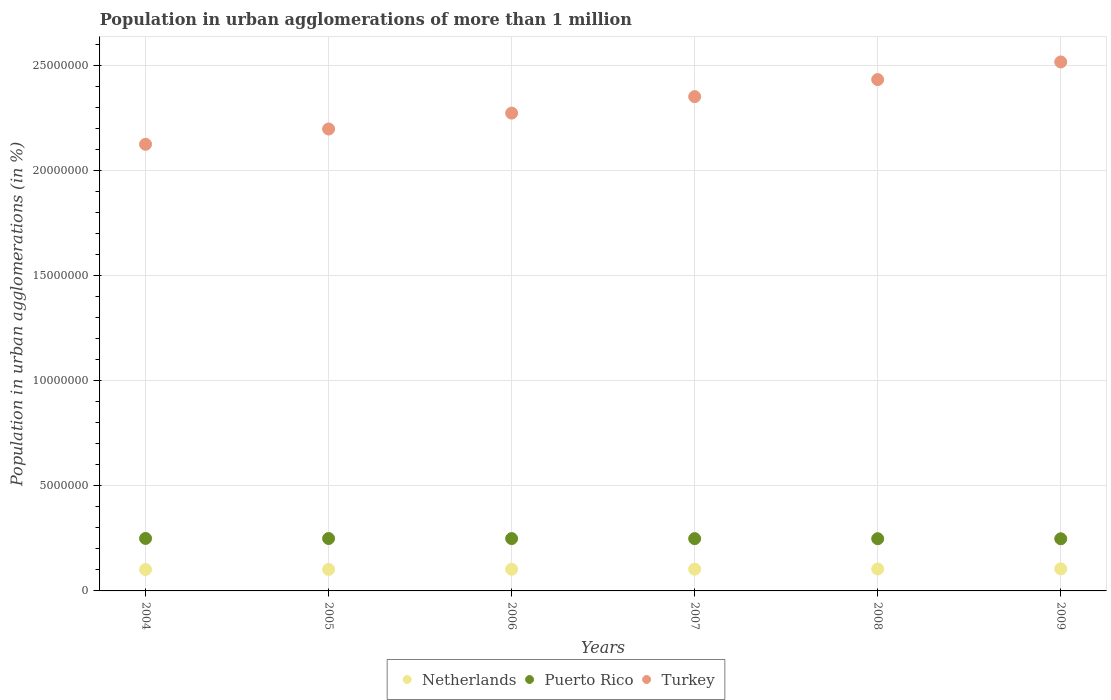Is the number of dotlines equal to the number of legend labels?
Provide a short and direct response. Yes. What is the population in urban agglomerations in Puerto Rico in 2004?
Make the answer very short. 2.50e+06. Across all years, what is the maximum population in urban agglomerations in Netherlands?
Your response must be concise. 1.05e+06. Across all years, what is the minimum population in urban agglomerations in Netherlands?
Make the answer very short. 1.02e+06. In which year was the population in urban agglomerations in Turkey maximum?
Your response must be concise. 2009. In which year was the population in urban agglomerations in Netherlands minimum?
Your answer should be compact. 2004. What is the total population in urban agglomerations in Turkey in the graph?
Provide a succinct answer. 1.39e+08. What is the difference between the population in urban agglomerations in Netherlands in 2004 and that in 2007?
Offer a terse response. -1.79e+04. What is the difference between the population in urban agglomerations in Turkey in 2004 and the population in urban agglomerations in Puerto Rico in 2007?
Your answer should be very brief. 1.88e+07. What is the average population in urban agglomerations in Puerto Rico per year?
Provide a short and direct response. 2.49e+06. In the year 2005, what is the difference between the population in urban agglomerations in Netherlands and population in urban agglomerations in Puerto Rico?
Provide a succinct answer. -1.47e+06. In how many years, is the population in urban agglomerations in Netherlands greater than 25000000 %?
Ensure brevity in your answer.  0. What is the ratio of the population in urban agglomerations in Turkey in 2004 to that in 2007?
Your answer should be very brief. 0.9. What is the difference between the highest and the second highest population in urban agglomerations in Netherlands?
Your answer should be very brief. 6563. What is the difference between the highest and the lowest population in urban agglomerations in Turkey?
Your answer should be very brief. 3.92e+06. Is the sum of the population in urban agglomerations in Turkey in 2004 and 2007 greater than the maximum population in urban agglomerations in Puerto Rico across all years?
Provide a succinct answer. Yes. Does the population in urban agglomerations in Puerto Rico monotonically increase over the years?
Your answer should be compact. No. Is the population in urban agglomerations in Netherlands strictly less than the population in urban agglomerations in Turkey over the years?
Your answer should be very brief. Yes. How many years are there in the graph?
Offer a terse response. 6. Does the graph contain grids?
Give a very brief answer. Yes. Where does the legend appear in the graph?
Make the answer very short. Bottom center. What is the title of the graph?
Your answer should be very brief. Population in urban agglomerations of more than 1 million. What is the label or title of the X-axis?
Your answer should be very brief. Years. What is the label or title of the Y-axis?
Offer a terse response. Population in urban agglomerations (in %). What is the Population in urban agglomerations (in %) in Netherlands in 2004?
Your response must be concise. 1.02e+06. What is the Population in urban agglomerations (in %) of Puerto Rico in 2004?
Give a very brief answer. 2.50e+06. What is the Population in urban agglomerations (in %) in Turkey in 2004?
Ensure brevity in your answer.  2.12e+07. What is the Population in urban agglomerations (in %) in Netherlands in 2005?
Your response must be concise. 1.02e+06. What is the Population in urban agglomerations (in %) of Puerto Rico in 2005?
Offer a terse response. 2.49e+06. What is the Population in urban agglomerations (in %) in Turkey in 2005?
Provide a succinct answer. 2.20e+07. What is the Population in urban agglomerations (in %) of Netherlands in 2006?
Offer a terse response. 1.03e+06. What is the Population in urban agglomerations (in %) in Puerto Rico in 2006?
Your answer should be compact. 2.49e+06. What is the Population in urban agglomerations (in %) of Turkey in 2006?
Keep it short and to the point. 2.27e+07. What is the Population in urban agglomerations (in %) of Netherlands in 2007?
Give a very brief answer. 1.04e+06. What is the Population in urban agglomerations (in %) of Puerto Rico in 2007?
Offer a very short reply. 2.49e+06. What is the Population in urban agglomerations (in %) in Turkey in 2007?
Offer a very short reply. 2.35e+07. What is the Population in urban agglomerations (in %) in Netherlands in 2008?
Your answer should be compact. 1.04e+06. What is the Population in urban agglomerations (in %) in Puerto Rico in 2008?
Keep it short and to the point. 2.48e+06. What is the Population in urban agglomerations (in %) of Turkey in 2008?
Your answer should be compact. 2.43e+07. What is the Population in urban agglomerations (in %) in Netherlands in 2009?
Provide a succinct answer. 1.05e+06. What is the Population in urban agglomerations (in %) of Puerto Rico in 2009?
Make the answer very short. 2.48e+06. What is the Population in urban agglomerations (in %) in Turkey in 2009?
Offer a very short reply. 2.52e+07. Across all years, what is the maximum Population in urban agglomerations (in %) in Netherlands?
Give a very brief answer. 1.05e+06. Across all years, what is the maximum Population in urban agglomerations (in %) of Puerto Rico?
Your answer should be very brief. 2.50e+06. Across all years, what is the maximum Population in urban agglomerations (in %) of Turkey?
Keep it short and to the point. 2.52e+07. Across all years, what is the minimum Population in urban agglomerations (in %) of Netherlands?
Provide a succinct answer. 1.02e+06. Across all years, what is the minimum Population in urban agglomerations (in %) in Puerto Rico?
Keep it short and to the point. 2.48e+06. Across all years, what is the minimum Population in urban agglomerations (in %) in Turkey?
Your answer should be very brief. 2.12e+07. What is the total Population in urban agglomerations (in %) in Netherlands in the graph?
Provide a succinct answer. 6.20e+06. What is the total Population in urban agglomerations (in %) of Puerto Rico in the graph?
Provide a succinct answer. 1.49e+07. What is the total Population in urban agglomerations (in %) in Turkey in the graph?
Provide a short and direct response. 1.39e+08. What is the difference between the Population in urban agglomerations (in %) of Netherlands in 2004 and that in 2005?
Your response must be concise. -5006. What is the difference between the Population in urban agglomerations (in %) in Puerto Rico in 2004 and that in 2005?
Keep it short and to the point. 3008. What is the difference between the Population in urban agglomerations (in %) in Turkey in 2004 and that in 2005?
Give a very brief answer. -7.29e+05. What is the difference between the Population in urban agglomerations (in %) in Netherlands in 2004 and that in 2006?
Provide a succinct answer. -1.15e+04. What is the difference between the Population in urban agglomerations (in %) in Puerto Rico in 2004 and that in 2006?
Your response must be concise. 6016. What is the difference between the Population in urban agglomerations (in %) in Turkey in 2004 and that in 2006?
Give a very brief answer. -1.49e+06. What is the difference between the Population in urban agglomerations (in %) of Netherlands in 2004 and that in 2007?
Offer a terse response. -1.79e+04. What is the difference between the Population in urban agglomerations (in %) of Puerto Rico in 2004 and that in 2007?
Provide a short and direct response. 9020. What is the difference between the Population in urban agglomerations (in %) in Turkey in 2004 and that in 2007?
Provide a short and direct response. -2.27e+06. What is the difference between the Population in urban agglomerations (in %) of Netherlands in 2004 and that in 2008?
Offer a terse response. -2.45e+04. What is the difference between the Population in urban agglomerations (in %) in Puerto Rico in 2004 and that in 2008?
Give a very brief answer. 1.20e+04. What is the difference between the Population in urban agglomerations (in %) of Turkey in 2004 and that in 2008?
Your answer should be compact. -3.08e+06. What is the difference between the Population in urban agglomerations (in %) of Netherlands in 2004 and that in 2009?
Your answer should be compact. -3.10e+04. What is the difference between the Population in urban agglomerations (in %) in Puerto Rico in 2004 and that in 2009?
Your response must be concise. 1.50e+04. What is the difference between the Population in urban agglomerations (in %) of Turkey in 2004 and that in 2009?
Your answer should be compact. -3.92e+06. What is the difference between the Population in urban agglomerations (in %) in Netherlands in 2005 and that in 2006?
Offer a very short reply. -6450. What is the difference between the Population in urban agglomerations (in %) in Puerto Rico in 2005 and that in 2006?
Offer a very short reply. 3008. What is the difference between the Population in urban agglomerations (in %) in Turkey in 2005 and that in 2006?
Your response must be concise. -7.56e+05. What is the difference between the Population in urban agglomerations (in %) of Netherlands in 2005 and that in 2007?
Offer a very short reply. -1.29e+04. What is the difference between the Population in urban agglomerations (in %) in Puerto Rico in 2005 and that in 2007?
Offer a very short reply. 6012. What is the difference between the Population in urban agglomerations (in %) in Turkey in 2005 and that in 2007?
Provide a succinct answer. -1.54e+06. What is the difference between the Population in urban agglomerations (in %) in Netherlands in 2005 and that in 2008?
Your response must be concise. -1.95e+04. What is the difference between the Population in urban agglomerations (in %) in Puerto Rico in 2005 and that in 2008?
Ensure brevity in your answer.  9017. What is the difference between the Population in urban agglomerations (in %) in Turkey in 2005 and that in 2008?
Offer a terse response. -2.35e+06. What is the difference between the Population in urban agglomerations (in %) of Netherlands in 2005 and that in 2009?
Give a very brief answer. -2.60e+04. What is the difference between the Population in urban agglomerations (in %) of Puerto Rico in 2005 and that in 2009?
Offer a terse response. 1.20e+04. What is the difference between the Population in urban agglomerations (in %) of Turkey in 2005 and that in 2009?
Your response must be concise. -3.19e+06. What is the difference between the Population in urban agglomerations (in %) in Netherlands in 2006 and that in 2007?
Your answer should be compact. -6490. What is the difference between the Population in urban agglomerations (in %) in Puerto Rico in 2006 and that in 2007?
Your answer should be very brief. 3004. What is the difference between the Population in urban agglomerations (in %) of Turkey in 2006 and that in 2007?
Make the answer very short. -7.83e+05. What is the difference between the Population in urban agglomerations (in %) in Netherlands in 2006 and that in 2008?
Ensure brevity in your answer.  -1.30e+04. What is the difference between the Population in urban agglomerations (in %) of Puerto Rico in 2006 and that in 2008?
Keep it short and to the point. 6009. What is the difference between the Population in urban agglomerations (in %) in Turkey in 2006 and that in 2008?
Provide a succinct answer. -1.59e+06. What is the difference between the Population in urban agglomerations (in %) of Netherlands in 2006 and that in 2009?
Your response must be concise. -1.96e+04. What is the difference between the Population in urban agglomerations (in %) in Puerto Rico in 2006 and that in 2009?
Offer a terse response. 9002. What is the difference between the Population in urban agglomerations (in %) in Turkey in 2006 and that in 2009?
Give a very brief answer. -2.43e+06. What is the difference between the Population in urban agglomerations (in %) of Netherlands in 2007 and that in 2008?
Offer a terse response. -6540. What is the difference between the Population in urban agglomerations (in %) of Puerto Rico in 2007 and that in 2008?
Make the answer very short. 3005. What is the difference between the Population in urban agglomerations (in %) of Turkey in 2007 and that in 2008?
Provide a short and direct response. -8.12e+05. What is the difference between the Population in urban agglomerations (in %) of Netherlands in 2007 and that in 2009?
Your response must be concise. -1.31e+04. What is the difference between the Population in urban agglomerations (in %) of Puerto Rico in 2007 and that in 2009?
Ensure brevity in your answer.  5998. What is the difference between the Population in urban agglomerations (in %) in Turkey in 2007 and that in 2009?
Your response must be concise. -1.65e+06. What is the difference between the Population in urban agglomerations (in %) of Netherlands in 2008 and that in 2009?
Your answer should be very brief. -6563. What is the difference between the Population in urban agglomerations (in %) of Puerto Rico in 2008 and that in 2009?
Provide a short and direct response. 2993. What is the difference between the Population in urban agglomerations (in %) in Turkey in 2008 and that in 2009?
Your response must be concise. -8.39e+05. What is the difference between the Population in urban agglomerations (in %) of Netherlands in 2004 and the Population in urban agglomerations (in %) of Puerto Rico in 2005?
Your answer should be compact. -1.47e+06. What is the difference between the Population in urban agglomerations (in %) of Netherlands in 2004 and the Population in urban agglomerations (in %) of Turkey in 2005?
Your answer should be compact. -2.10e+07. What is the difference between the Population in urban agglomerations (in %) of Puerto Rico in 2004 and the Population in urban agglomerations (in %) of Turkey in 2005?
Provide a short and direct response. -1.95e+07. What is the difference between the Population in urban agglomerations (in %) in Netherlands in 2004 and the Population in urban agglomerations (in %) in Puerto Rico in 2006?
Ensure brevity in your answer.  -1.47e+06. What is the difference between the Population in urban agglomerations (in %) in Netherlands in 2004 and the Population in urban agglomerations (in %) in Turkey in 2006?
Ensure brevity in your answer.  -2.17e+07. What is the difference between the Population in urban agglomerations (in %) of Puerto Rico in 2004 and the Population in urban agglomerations (in %) of Turkey in 2006?
Your answer should be compact. -2.02e+07. What is the difference between the Population in urban agglomerations (in %) in Netherlands in 2004 and the Population in urban agglomerations (in %) in Puerto Rico in 2007?
Offer a very short reply. -1.47e+06. What is the difference between the Population in urban agglomerations (in %) in Netherlands in 2004 and the Population in urban agglomerations (in %) in Turkey in 2007?
Provide a succinct answer. -2.25e+07. What is the difference between the Population in urban agglomerations (in %) in Puerto Rico in 2004 and the Population in urban agglomerations (in %) in Turkey in 2007?
Your answer should be compact. -2.10e+07. What is the difference between the Population in urban agglomerations (in %) of Netherlands in 2004 and the Population in urban agglomerations (in %) of Puerto Rico in 2008?
Provide a succinct answer. -1.47e+06. What is the difference between the Population in urban agglomerations (in %) of Netherlands in 2004 and the Population in urban agglomerations (in %) of Turkey in 2008?
Your answer should be compact. -2.33e+07. What is the difference between the Population in urban agglomerations (in %) in Puerto Rico in 2004 and the Population in urban agglomerations (in %) in Turkey in 2008?
Keep it short and to the point. -2.18e+07. What is the difference between the Population in urban agglomerations (in %) of Netherlands in 2004 and the Population in urban agglomerations (in %) of Puerto Rico in 2009?
Your response must be concise. -1.46e+06. What is the difference between the Population in urban agglomerations (in %) of Netherlands in 2004 and the Population in urban agglomerations (in %) of Turkey in 2009?
Give a very brief answer. -2.41e+07. What is the difference between the Population in urban agglomerations (in %) of Puerto Rico in 2004 and the Population in urban agglomerations (in %) of Turkey in 2009?
Provide a succinct answer. -2.27e+07. What is the difference between the Population in urban agglomerations (in %) of Netherlands in 2005 and the Population in urban agglomerations (in %) of Puerto Rico in 2006?
Offer a very short reply. -1.47e+06. What is the difference between the Population in urban agglomerations (in %) in Netherlands in 2005 and the Population in urban agglomerations (in %) in Turkey in 2006?
Offer a terse response. -2.17e+07. What is the difference between the Population in urban agglomerations (in %) in Puerto Rico in 2005 and the Population in urban agglomerations (in %) in Turkey in 2006?
Make the answer very short. -2.02e+07. What is the difference between the Population in urban agglomerations (in %) in Netherlands in 2005 and the Population in urban agglomerations (in %) in Puerto Rico in 2007?
Offer a very short reply. -1.46e+06. What is the difference between the Population in urban agglomerations (in %) of Netherlands in 2005 and the Population in urban agglomerations (in %) of Turkey in 2007?
Offer a very short reply. -2.25e+07. What is the difference between the Population in urban agglomerations (in %) in Puerto Rico in 2005 and the Population in urban agglomerations (in %) in Turkey in 2007?
Provide a short and direct response. -2.10e+07. What is the difference between the Population in urban agglomerations (in %) of Netherlands in 2005 and the Population in urban agglomerations (in %) of Puerto Rico in 2008?
Your answer should be very brief. -1.46e+06. What is the difference between the Population in urban agglomerations (in %) in Netherlands in 2005 and the Population in urban agglomerations (in %) in Turkey in 2008?
Provide a succinct answer. -2.33e+07. What is the difference between the Population in urban agglomerations (in %) of Puerto Rico in 2005 and the Population in urban agglomerations (in %) of Turkey in 2008?
Provide a succinct answer. -2.18e+07. What is the difference between the Population in urban agglomerations (in %) in Netherlands in 2005 and the Population in urban agglomerations (in %) in Puerto Rico in 2009?
Provide a succinct answer. -1.46e+06. What is the difference between the Population in urban agglomerations (in %) of Netherlands in 2005 and the Population in urban agglomerations (in %) of Turkey in 2009?
Offer a very short reply. -2.41e+07. What is the difference between the Population in urban agglomerations (in %) in Puerto Rico in 2005 and the Population in urban agglomerations (in %) in Turkey in 2009?
Your answer should be very brief. -2.27e+07. What is the difference between the Population in urban agglomerations (in %) of Netherlands in 2006 and the Population in urban agglomerations (in %) of Puerto Rico in 2007?
Offer a very short reply. -1.46e+06. What is the difference between the Population in urban agglomerations (in %) in Netherlands in 2006 and the Population in urban agglomerations (in %) in Turkey in 2007?
Your answer should be compact. -2.25e+07. What is the difference between the Population in urban agglomerations (in %) of Puerto Rico in 2006 and the Population in urban agglomerations (in %) of Turkey in 2007?
Provide a succinct answer. -2.10e+07. What is the difference between the Population in urban agglomerations (in %) in Netherlands in 2006 and the Population in urban agglomerations (in %) in Puerto Rico in 2008?
Provide a short and direct response. -1.45e+06. What is the difference between the Population in urban agglomerations (in %) of Netherlands in 2006 and the Population in urban agglomerations (in %) of Turkey in 2008?
Give a very brief answer. -2.33e+07. What is the difference between the Population in urban agglomerations (in %) of Puerto Rico in 2006 and the Population in urban agglomerations (in %) of Turkey in 2008?
Offer a very short reply. -2.18e+07. What is the difference between the Population in urban agglomerations (in %) of Netherlands in 2006 and the Population in urban agglomerations (in %) of Puerto Rico in 2009?
Give a very brief answer. -1.45e+06. What is the difference between the Population in urban agglomerations (in %) of Netherlands in 2006 and the Population in urban agglomerations (in %) of Turkey in 2009?
Your response must be concise. -2.41e+07. What is the difference between the Population in urban agglomerations (in %) of Puerto Rico in 2006 and the Population in urban agglomerations (in %) of Turkey in 2009?
Ensure brevity in your answer.  -2.27e+07. What is the difference between the Population in urban agglomerations (in %) in Netherlands in 2007 and the Population in urban agglomerations (in %) in Puerto Rico in 2008?
Give a very brief answer. -1.45e+06. What is the difference between the Population in urban agglomerations (in %) of Netherlands in 2007 and the Population in urban agglomerations (in %) of Turkey in 2008?
Give a very brief answer. -2.33e+07. What is the difference between the Population in urban agglomerations (in %) in Puerto Rico in 2007 and the Population in urban agglomerations (in %) in Turkey in 2008?
Give a very brief answer. -2.18e+07. What is the difference between the Population in urban agglomerations (in %) of Netherlands in 2007 and the Population in urban agglomerations (in %) of Puerto Rico in 2009?
Ensure brevity in your answer.  -1.44e+06. What is the difference between the Population in urban agglomerations (in %) in Netherlands in 2007 and the Population in urban agglomerations (in %) in Turkey in 2009?
Provide a succinct answer. -2.41e+07. What is the difference between the Population in urban agglomerations (in %) of Puerto Rico in 2007 and the Population in urban agglomerations (in %) of Turkey in 2009?
Make the answer very short. -2.27e+07. What is the difference between the Population in urban agglomerations (in %) of Netherlands in 2008 and the Population in urban agglomerations (in %) of Puerto Rico in 2009?
Ensure brevity in your answer.  -1.44e+06. What is the difference between the Population in urban agglomerations (in %) in Netherlands in 2008 and the Population in urban agglomerations (in %) in Turkey in 2009?
Provide a short and direct response. -2.41e+07. What is the difference between the Population in urban agglomerations (in %) in Puerto Rico in 2008 and the Population in urban agglomerations (in %) in Turkey in 2009?
Offer a terse response. -2.27e+07. What is the average Population in urban agglomerations (in %) in Netherlands per year?
Offer a terse response. 1.03e+06. What is the average Population in urban agglomerations (in %) of Puerto Rico per year?
Ensure brevity in your answer.  2.49e+06. What is the average Population in urban agglomerations (in %) of Turkey per year?
Give a very brief answer. 2.32e+07. In the year 2004, what is the difference between the Population in urban agglomerations (in %) of Netherlands and Population in urban agglomerations (in %) of Puerto Rico?
Give a very brief answer. -1.48e+06. In the year 2004, what is the difference between the Population in urban agglomerations (in %) of Netherlands and Population in urban agglomerations (in %) of Turkey?
Give a very brief answer. -2.02e+07. In the year 2004, what is the difference between the Population in urban agglomerations (in %) in Puerto Rico and Population in urban agglomerations (in %) in Turkey?
Your response must be concise. -1.88e+07. In the year 2005, what is the difference between the Population in urban agglomerations (in %) of Netherlands and Population in urban agglomerations (in %) of Puerto Rico?
Offer a very short reply. -1.47e+06. In the year 2005, what is the difference between the Population in urban agglomerations (in %) of Netherlands and Population in urban agglomerations (in %) of Turkey?
Make the answer very short. -2.10e+07. In the year 2005, what is the difference between the Population in urban agglomerations (in %) of Puerto Rico and Population in urban agglomerations (in %) of Turkey?
Keep it short and to the point. -1.95e+07. In the year 2006, what is the difference between the Population in urban agglomerations (in %) in Netherlands and Population in urban agglomerations (in %) in Puerto Rico?
Make the answer very short. -1.46e+06. In the year 2006, what is the difference between the Population in urban agglomerations (in %) in Netherlands and Population in urban agglomerations (in %) in Turkey?
Offer a terse response. -2.17e+07. In the year 2006, what is the difference between the Population in urban agglomerations (in %) in Puerto Rico and Population in urban agglomerations (in %) in Turkey?
Give a very brief answer. -2.02e+07. In the year 2007, what is the difference between the Population in urban agglomerations (in %) in Netherlands and Population in urban agglomerations (in %) in Puerto Rico?
Give a very brief answer. -1.45e+06. In the year 2007, what is the difference between the Population in urban agglomerations (in %) of Netherlands and Population in urban agglomerations (in %) of Turkey?
Make the answer very short. -2.25e+07. In the year 2007, what is the difference between the Population in urban agglomerations (in %) in Puerto Rico and Population in urban agglomerations (in %) in Turkey?
Give a very brief answer. -2.10e+07. In the year 2008, what is the difference between the Population in urban agglomerations (in %) of Netherlands and Population in urban agglomerations (in %) of Puerto Rico?
Your answer should be compact. -1.44e+06. In the year 2008, what is the difference between the Population in urban agglomerations (in %) in Netherlands and Population in urban agglomerations (in %) in Turkey?
Your answer should be compact. -2.33e+07. In the year 2008, what is the difference between the Population in urban agglomerations (in %) of Puerto Rico and Population in urban agglomerations (in %) of Turkey?
Your response must be concise. -2.18e+07. In the year 2009, what is the difference between the Population in urban agglomerations (in %) of Netherlands and Population in urban agglomerations (in %) of Puerto Rico?
Your answer should be compact. -1.43e+06. In the year 2009, what is the difference between the Population in urban agglomerations (in %) in Netherlands and Population in urban agglomerations (in %) in Turkey?
Offer a terse response. -2.41e+07. In the year 2009, what is the difference between the Population in urban agglomerations (in %) of Puerto Rico and Population in urban agglomerations (in %) of Turkey?
Offer a terse response. -2.27e+07. What is the ratio of the Population in urban agglomerations (in %) in Netherlands in 2004 to that in 2005?
Your answer should be compact. 1. What is the ratio of the Population in urban agglomerations (in %) of Turkey in 2004 to that in 2005?
Keep it short and to the point. 0.97. What is the ratio of the Population in urban agglomerations (in %) of Netherlands in 2004 to that in 2006?
Offer a terse response. 0.99. What is the ratio of the Population in urban agglomerations (in %) of Puerto Rico in 2004 to that in 2006?
Your answer should be very brief. 1. What is the ratio of the Population in urban agglomerations (in %) in Turkey in 2004 to that in 2006?
Keep it short and to the point. 0.93. What is the ratio of the Population in urban agglomerations (in %) of Netherlands in 2004 to that in 2007?
Provide a short and direct response. 0.98. What is the ratio of the Population in urban agglomerations (in %) of Puerto Rico in 2004 to that in 2007?
Offer a terse response. 1. What is the ratio of the Population in urban agglomerations (in %) in Turkey in 2004 to that in 2007?
Offer a terse response. 0.9. What is the ratio of the Population in urban agglomerations (in %) of Netherlands in 2004 to that in 2008?
Make the answer very short. 0.98. What is the ratio of the Population in urban agglomerations (in %) of Turkey in 2004 to that in 2008?
Ensure brevity in your answer.  0.87. What is the ratio of the Population in urban agglomerations (in %) in Netherlands in 2004 to that in 2009?
Keep it short and to the point. 0.97. What is the ratio of the Population in urban agglomerations (in %) of Turkey in 2004 to that in 2009?
Give a very brief answer. 0.84. What is the ratio of the Population in urban agglomerations (in %) of Puerto Rico in 2005 to that in 2006?
Your answer should be compact. 1. What is the ratio of the Population in urban agglomerations (in %) in Turkey in 2005 to that in 2006?
Keep it short and to the point. 0.97. What is the ratio of the Population in urban agglomerations (in %) of Netherlands in 2005 to that in 2007?
Your answer should be very brief. 0.99. What is the ratio of the Population in urban agglomerations (in %) of Turkey in 2005 to that in 2007?
Provide a succinct answer. 0.93. What is the ratio of the Population in urban agglomerations (in %) of Netherlands in 2005 to that in 2008?
Provide a succinct answer. 0.98. What is the ratio of the Population in urban agglomerations (in %) in Puerto Rico in 2005 to that in 2008?
Ensure brevity in your answer.  1. What is the ratio of the Population in urban agglomerations (in %) of Turkey in 2005 to that in 2008?
Ensure brevity in your answer.  0.9. What is the ratio of the Population in urban agglomerations (in %) of Netherlands in 2005 to that in 2009?
Give a very brief answer. 0.98. What is the ratio of the Population in urban agglomerations (in %) of Puerto Rico in 2005 to that in 2009?
Give a very brief answer. 1. What is the ratio of the Population in urban agglomerations (in %) of Turkey in 2005 to that in 2009?
Ensure brevity in your answer.  0.87. What is the ratio of the Population in urban agglomerations (in %) in Netherlands in 2006 to that in 2007?
Your answer should be compact. 0.99. What is the ratio of the Population in urban agglomerations (in %) in Puerto Rico in 2006 to that in 2007?
Make the answer very short. 1. What is the ratio of the Population in urban agglomerations (in %) of Turkey in 2006 to that in 2007?
Offer a terse response. 0.97. What is the ratio of the Population in urban agglomerations (in %) of Netherlands in 2006 to that in 2008?
Your answer should be very brief. 0.99. What is the ratio of the Population in urban agglomerations (in %) in Turkey in 2006 to that in 2008?
Provide a succinct answer. 0.93. What is the ratio of the Population in urban agglomerations (in %) of Netherlands in 2006 to that in 2009?
Keep it short and to the point. 0.98. What is the ratio of the Population in urban agglomerations (in %) of Puerto Rico in 2006 to that in 2009?
Your answer should be very brief. 1. What is the ratio of the Population in urban agglomerations (in %) of Turkey in 2006 to that in 2009?
Give a very brief answer. 0.9. What is the ratio of the Population in urban agglomerations (in %) in Netherlands in 2007 to that in 2008?
Offer a terse response. 0.99. What is the ratio of the Population in urban agglomerations (in %) of Turkey in 2007 to that in 2008?
Offer a very short reply. 0.97. What is the ratio of the Population in urban agglomerations (in %) of Netherlands in 2007 to that in 2009?
Your answer should be very brief. 0.99. What is the ratio of the Population in urban agglomerations (in %) in Turkey in 2007 to that in 2009?
Your answer should be compact. 0.93. What is the ratio of the Population in urban agglomerations (in %) in Turkey in 2008 to that in 2009?
Your response must be concise. 0.97. What is the difference between the highest and the second highest Population in urban agglomerations (in %) in Netherlands?
Ensure brevity in your answer.  6563. What is the difference between the highest and the second highest Population in urban agglomerations (in %) in Puerto Rico?
Your response must be concise. 3008. What is the difference between the highest and the second highest Population in urban agglomerations (in %) in Turkey?
Your response must be concise. 8.39e+05. What is the difference between the highest and the lowest Population in urban agglomerations (in %) in Netherlands?
Provide a short and direct response. 3.10e+04. What is the difference between the highest and the lowest Population in urban agglomerations (in %) in Puerto Rico?
Ensure brevity in your answer.  1.50e+04. What is the difference between the highest and the lowest Population in urban agglomerations (in %) in Turkey?
Make the answer very short. 3.92e+06. 